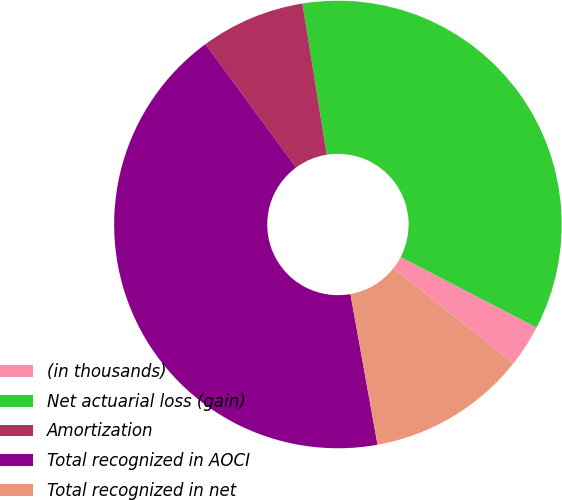Convert chart. <chart><loc_0><loc_0><loc_500><loc_500><pie_chart><fcel>(in thousands)<fcel>Net actuarial loss (gain)<fcel>Amortization<fcel>Total recognized in AOCI<fcel>Total recognized in net<nl><fcel>3.03%<fcel>35.15%<fcel>7.55%<fcel>42.75%<fcel>11.52%<nl></chart> 